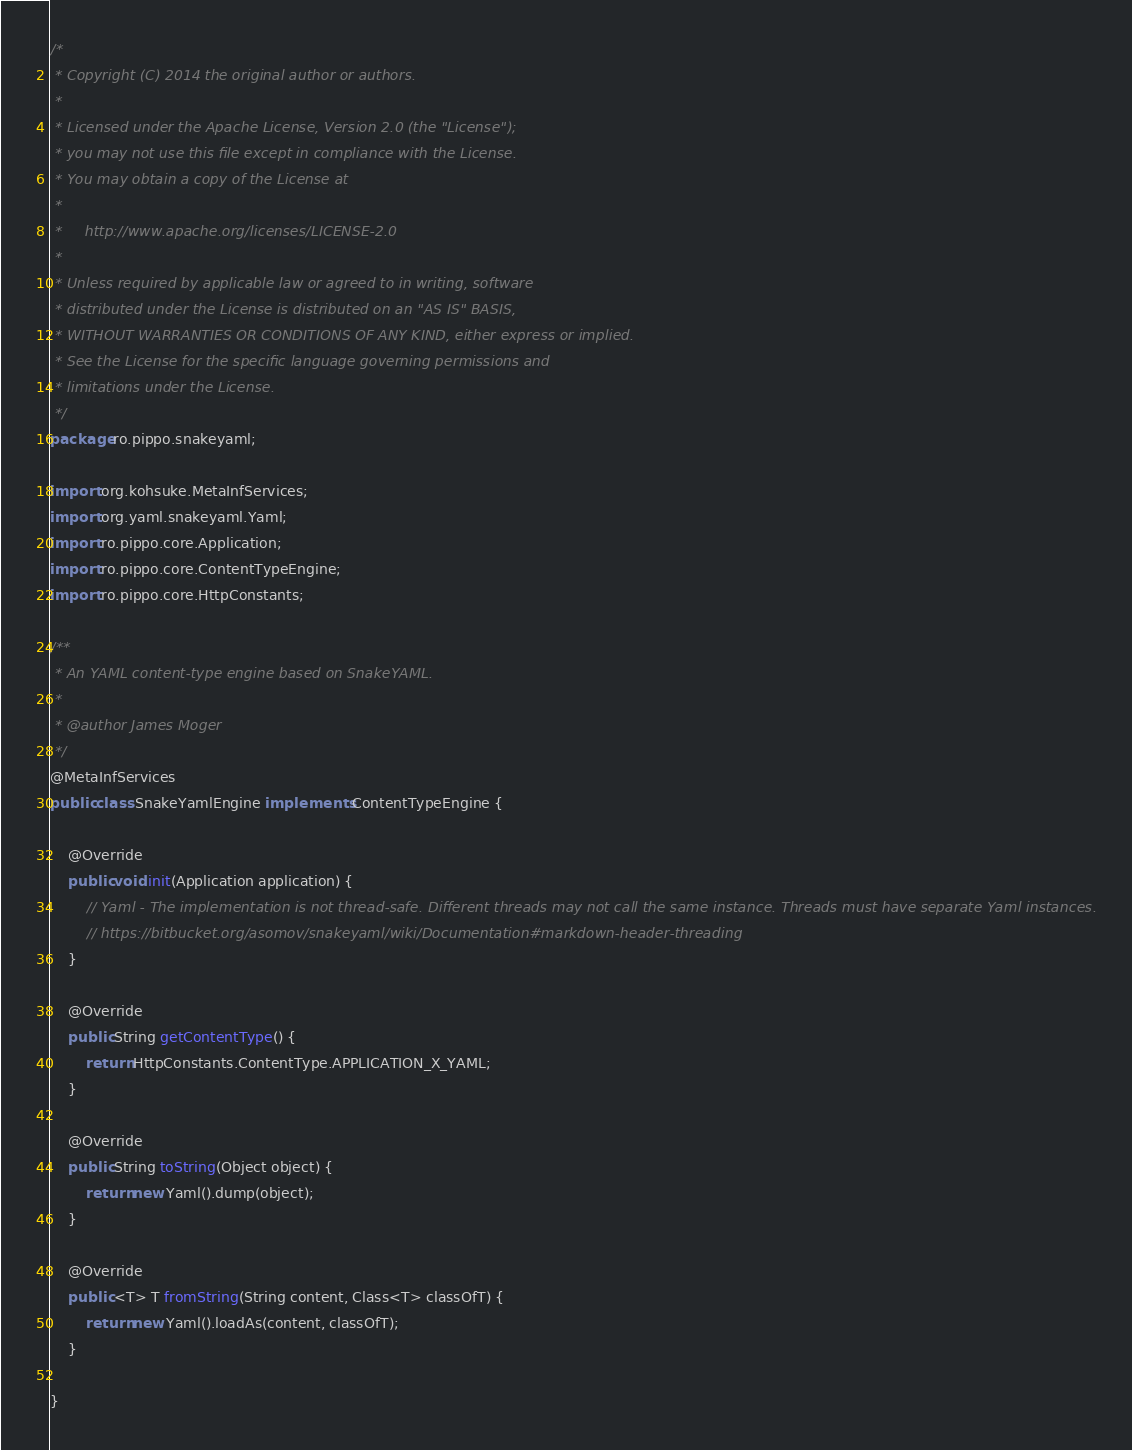Convert code to text. <code><loc_0><loc_0><loc_500><loc_500><_Java_>/*
 * Copyright (C) 2014 the original author or authors.
 *
 * Licensed under the Apache License, Version 2.0 (the "License");
 * you may not use this file except in compliance with the License.
 * You may obtain a copy of the License at
 *
 *     http://www.apache.org/licenses/LICENSE-2.0
 *
 * Unless required by applicable law or agreed to in writing, software
 * distributed under the License is distributed on an "AS IS" BASIS,
 * WITHOUT WARRANTIES OR CONDITIONS OF ANY KIND, either express or implied.
 * See the License for the specific language governing permissions and
 * limitations under the License.
 */
package ro.pippo.snakeyaml;

import org.kohsuke.MetaInfServices;
import org.yaml.snakeyaml.Yaml;
import ro.pippo.core.Application;
import ro.pippo.core.ContentTypeEngine;
import ro.pippo.core.HttpConstants;

/**
 * An YAML content-type engine based on SnakeYAML.
 *
 * @author James Moger
 */
@MetaInfServices
public class SnakeYamlEngine implements ContentTypeEngine {

    @Override
    public void init(Application application) {
        // Yaml - The implementation is not thread-safe. Different threads may not call the same instance. Threads must have separate Yaml instances.
        // https://bitbucket.org/asomov/snakeyaml/wiki/Documentation#markdown-header-threading
    }

    @Override
    public String getContentType() {
        return HttpConstants.ContentType.APPLICATION_X_YAML;
    }

    @Override
    public String toString(Object object) {
        return new Yaml().dump(object);
    }

    @Override
    public <T> T fromString(String content, Class<T> classOfT) {
        return new Yaml().loadAs(content, classOfT);
    }

}
</code> 